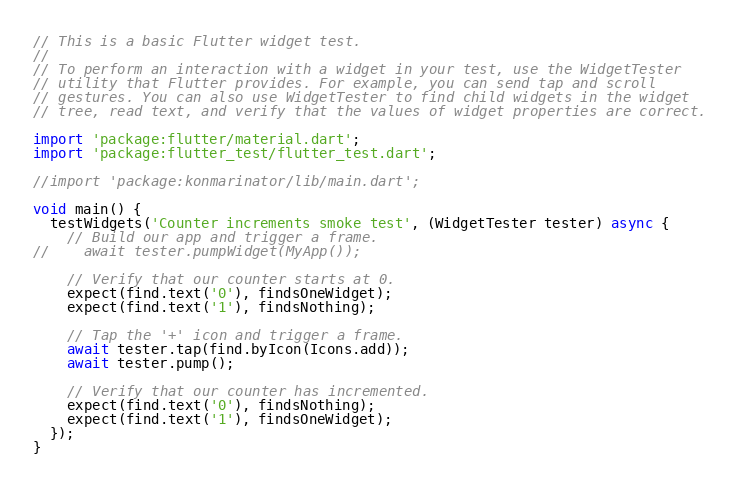<code> <loc_0><loc_0><loc_500><loc_500><_Dart_>// This is a basic Flutter widget test.
//
// To perform an interaction with a widget in your test, use the WidgetTester
// utility that Flutter provides. For example, you can send tap and scroll
// gestures. You can also use WidgetTester to find child widgets in the widget
// tree, read text, and verify that the values of widget properties are correct.

import 'package:flutter/material.dart';
import 'package:flutter_test/flutter_test.dart';

//import 'package:konmarinator/lib/main.dart';

void main() {
  testWidgets('Counter increments smoke test', (WidgetTester tester) async {
    // Build our app and trigger a frame.
//    await tester.pumpWidget(MyApp());

    // Verify that our counter starts at 0.
    expect(find.text('0'), findsOneWidget);
    expect(find.text('1'), findsNothing);

    // Tap the '+' icon and trigger a frame.
    await tester.tap(find.byIcon(Icons.add));
    await tester.pump();

    // Verify that our counter has incremented.
    expect(find.text('0'), findsNothing);
    expect(find.text('1'), findsOneWidget);
  });
}
</code> 